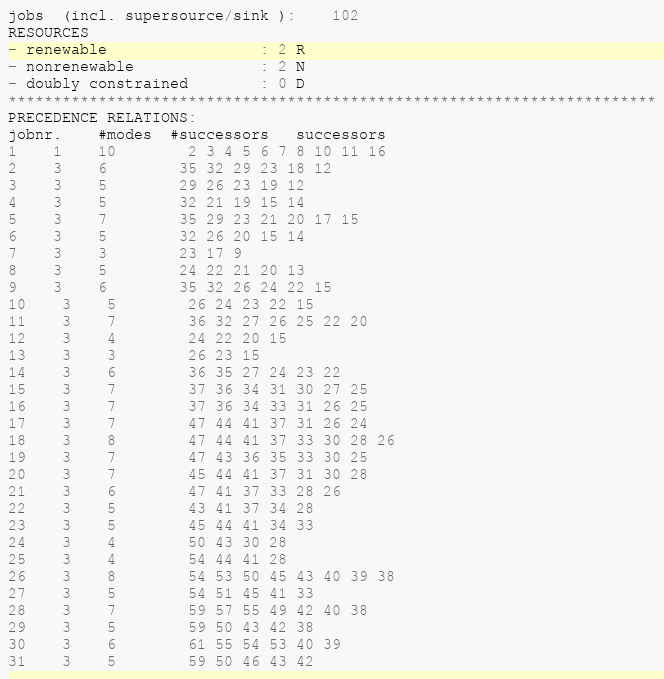Convert code to text. <code><loc_0><loc_0><loc_500><loc_500><_ObjectiveC_>jobs  (incl. supersource/sink ):	102
RESOURCES
- renewable                 : 2 R
- nonrenewable              : 2 N
- doubly constrained        : 0 D
************************************************************************
PRECEDENCE RELATIONS:
jobnr.    #modes  #successors   successors
1	1	10		2 3 4 5 6 7 8 10 11 16 
2	3	6		35 32 29 23 18 12 
3	3	5		29 26 23 19 12 
4	3	5		32 21 19 15 14 
5	3	7		35 29 23 21 20 17 15 
6	3	5		32 26 20 15 14 
7	3	3		23 17 9 
8	3	5		24 22 21 20 13 
9	3	6		35 32 26 24 22 15 
10	3	5		26 24 23 22 15 
11	3	7		36 32 27 26 25 22 20 
12	3	4		24 22 20 15 
13	3	3		26 23 15 
14	3	6		36 35 27 24 23 22 
15	3	7		37 36 34 31 30 27 25 
16	3	7		37 36 34 33 31 26 25 
17	3	7		47 44 41 37 31 26 24 
18	3	8		47 44 41 37 33 30 28 26 
19	3	7		47 43 36 35 33 30 25 
20	3	7		45 44 41 37 31 30 28 
21	3	6		47 41 37 33 28 26 
22	3	5		43 41 37 34 28 
23	3	5		45 44 41 34 33 
24	3	4		50 43 30 28 
25	3	4		54 44 41 28 
26	3	8		54 53 50 45 43 40 39 38 
27	3	5		54 51 45 41 33 
28	3	7		59 57 55 49 42 40 38 
29	3	5		59 50 43 42 38 
30	3	6		61 55 54 53 40 39 
31	3	5		59 50 46 43 42 </code> 